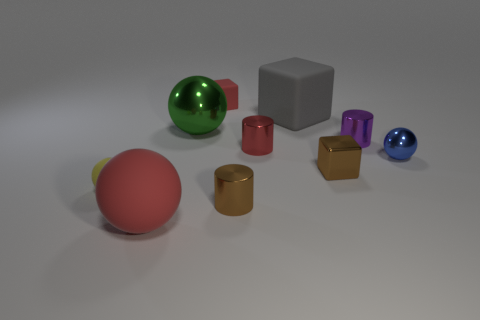Are there fewer red cylinders on the left side of the tiny red rubber object than tiny purple shiny cylinders?
Provide a succinct answer. Yes. What color is the small thing that is to the left of the red rubber object that is in front of the shiny block that is to the right of the red sphere?
Keep it short and to the point. Yellow. Is there any other thing that has the same material as the red cube?
Your response must be concise. Yes. There is a red thing that is the same shape as the big green object; what size is it?
Your answer should be compact. Large. Are there fewer tiny brown metallic cylinders behind the small yellow object than big gray things that are left of the tiny purple shiny object?
Give a very brief answer. Yes. What is the shape of the rubber thing that is behind the large red ball and in front of the small metal sphere?
Ensure brevity in your answer.  Sphere. The red object that is made of the same material as the large red sphere is what size?
Ensure brevity in your answer.  Small. Does the big shiny object have the same color as the block behind the gray rubber object?
Give a very brief answer. No. What is the material of the thing that is to the right of the big red thing and in front of the small yellow ball?
Offer a very short reply. Metal. What size is the metallic cylinder that is the same color as the shiny block?
Give a very brief answer. Small. 